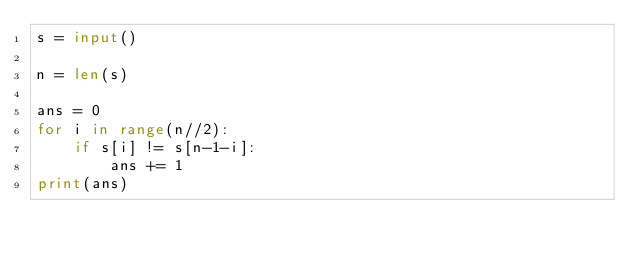<code> <loc_0><loc_0><loc_500><loc_500><_Python_>s = input()

n = len(s)

ans = 0 
for i in range(n//2):
    if s[i] != s[n-1-i]:
        ans += 1
print(ans)</code> 